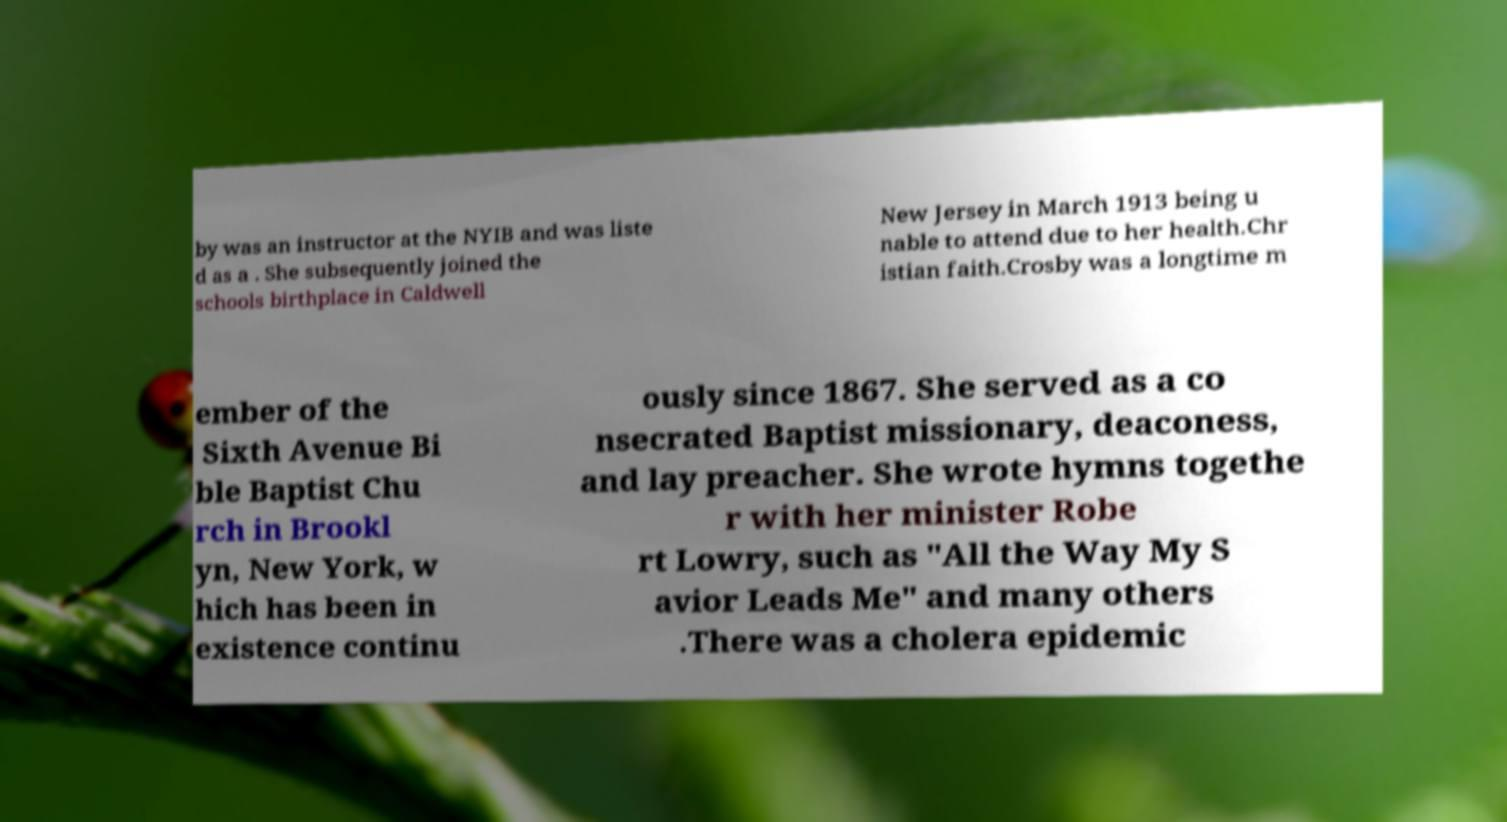Can you read and provide the text displayed in the image?This photo seems to have some interesting text. Can you extract and type it out for me? by was an instructor at the NYIB and was liste d as a . She subsequently joined the schools birthplace in Caldwell New Jersey in March 1913 being u nable to attend due to her health.Chr istian faith.Crosby was a longtime m ember of the Sixth Avenue Bi ble Baptist Chu rch in Brookl yn, New York, w hich has been in existence continu ously since 1867. She served as a co nsecrated Baptist missionary, deaconess, and lay preacher. She wrote hymns togethe r with her minister Robe rt Lowry, such as "All the Way My S avior Leads Me" and many others .There was a cholera epidemic 